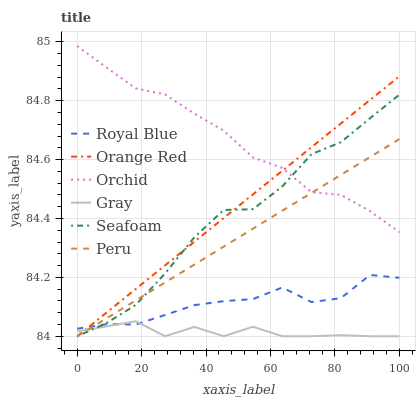Does Gray have the minimum area under the curve?
Answer yes or no. Yes. Does Orchid have the maximum area under the curve?
Answer yes or no. Yes. Does Seafoam have the minimum area under the curve?
Answer yes or no. No. Does Seafoam have the maximum area under the curve?
Answer yes or no. No. Is Peru the smoothest?
Answer yes or no. Yes. Is Seafoam the roughest?
Answer yes or no. Yes. Is Royal Blue the smoothest?
Answer yes or no. No. Is Royal Blue the roughest?
Answer yes or no. No. Does Gray have the lowest value?
Answer yes or no. Yes. Does Royal Blue have the lowest value?
Answer yes or no. No. Does Orchid have the highest value?
Answer yes or no. Yes. Does Seafoam have the highest value?
Answer yes or no. No. Is Gray less than Orchid?
Answer yes or no. Yes. Is Orchid greater than Gray?
Answer yes or no. Yes. Does Orange Red intersect Gray?
Answer yes or no. Yes. Is Orange Red less than Gray?
Answer yes or no. No. Is Orange Red greater than Gray?
Answer yes or no. No. Does Gray intersect Orchid?
Answer yes or no. No. 